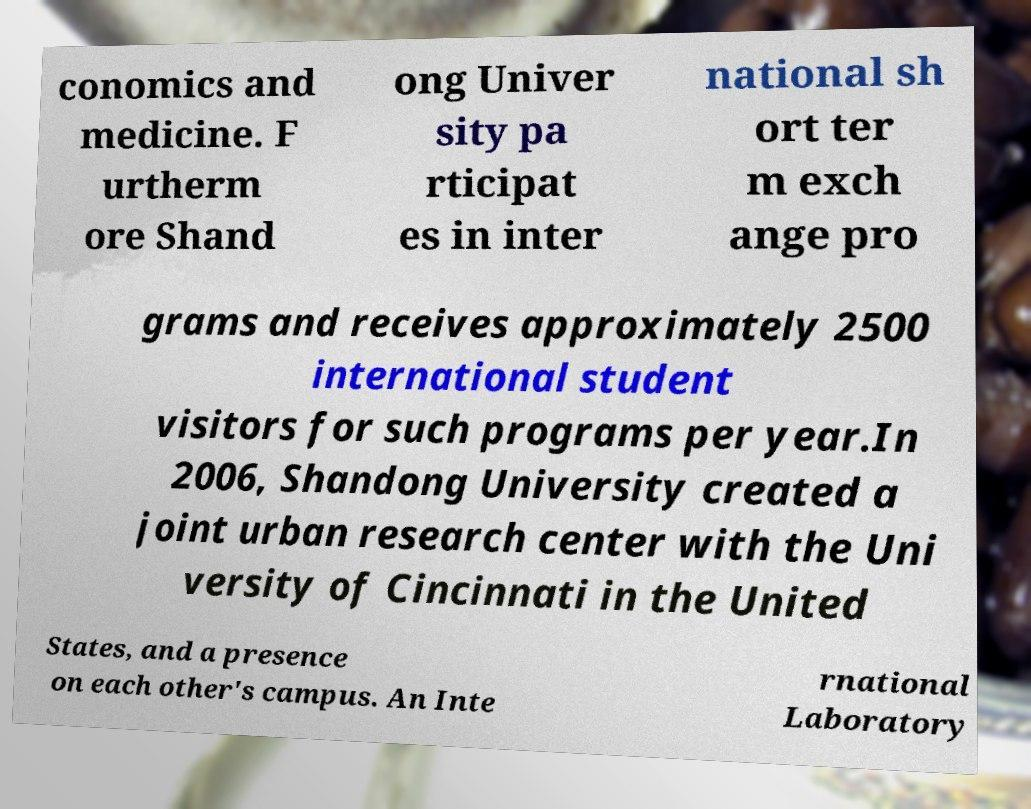I need the written content from this picture converted into text. Can you do that? conomics and medicine. F urtherm ore Shand ong Univer sity pa rticipat es in inter national sh ort ter m exch ange pro grams and receives approximately 2500 international student visitors for such programs per year.In 2006, Shandong University created a joint urban research center with the Uni versity of Cincinnati in the United States, and a presence on each other's campus. An Inte rnational Laboratory 